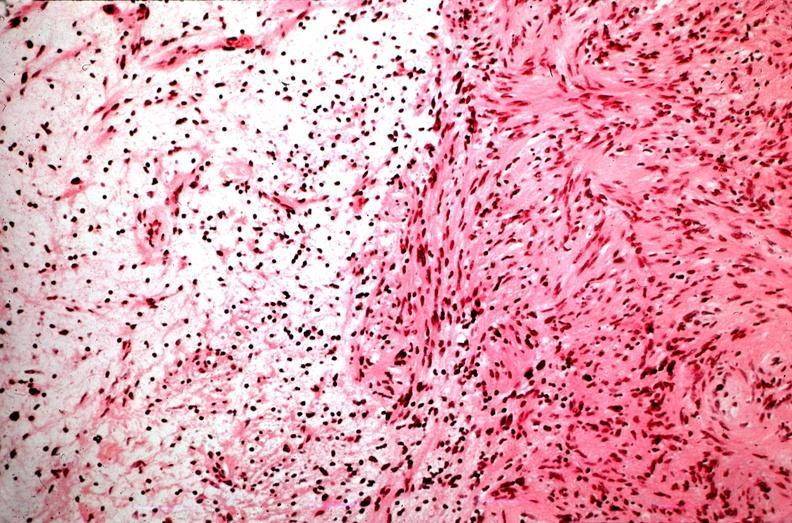s nervous present?
Answer the question using a single word or phrase. Yes 